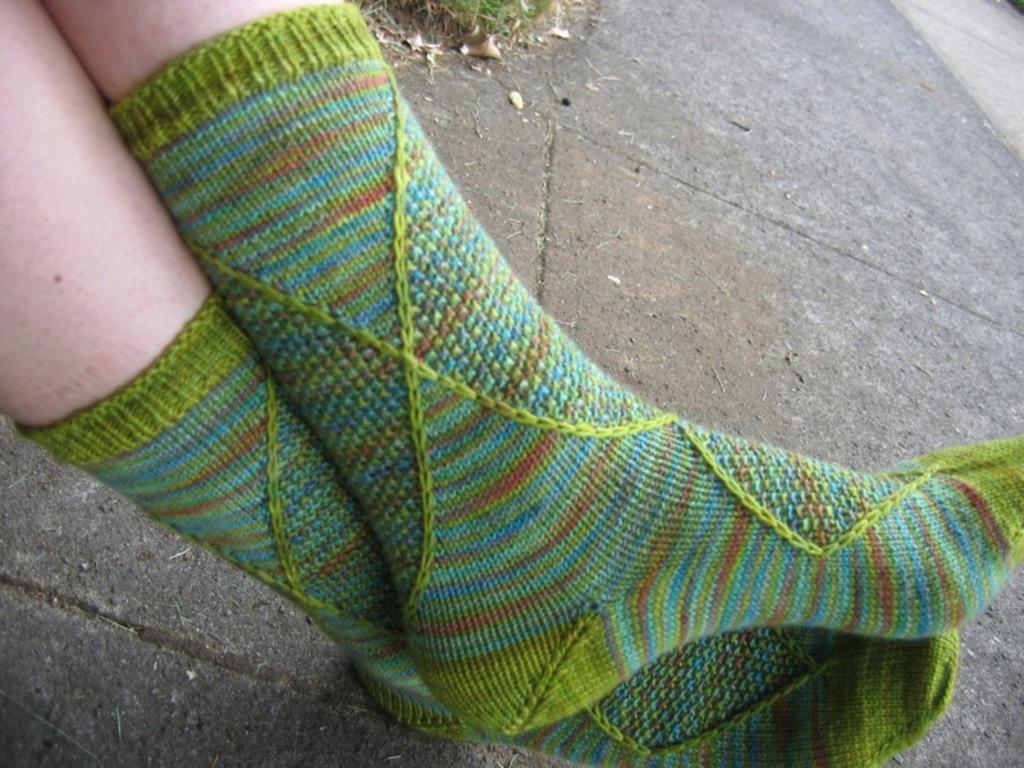Can you describe this image briefly? In this image we can see the legs of a person with socks on the ground. 